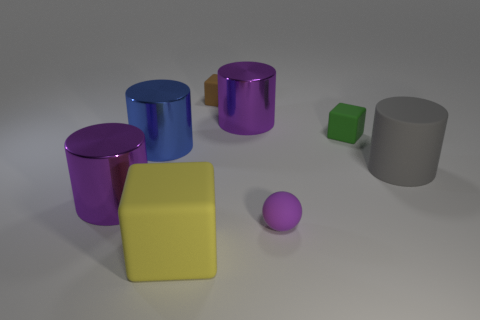There is a shiny cylinder that is to the right of the large blue metallic thing; is it the same color as the matte ball?
Make the answer very short. Yes. Are there any other things that are the same color as the small ball?
Provide a short and direct response. Yes. Is the number of green things that are right of the tiny purple sphere greater than the number of large yellow shiny balls?
Give a very brief answer. Yes. Is the yellow cube the same size as the green cube?
Provide a succinct answer. No. There is a blue thing that is the same shape as the gray matte thing; what is it made of?
Your response must be concise. Metal. Is there any other thing that has the same material as the blue cylinder?
Your response must be concise. Yes. How many red things are small objects or small cubes?
Provide a short and direct response. 0. What is the blue thing behind the purple rubber sphere made of?
Give a very brief answer. Metal. Is the number of large green matte objects greater than the number of small green rubber objects?
Your response must be concise. No. There is a big gray rubber thing that is on the right side of the brown block; is its shape the same as the blue object?
Keep it short and to the point. Yes. 